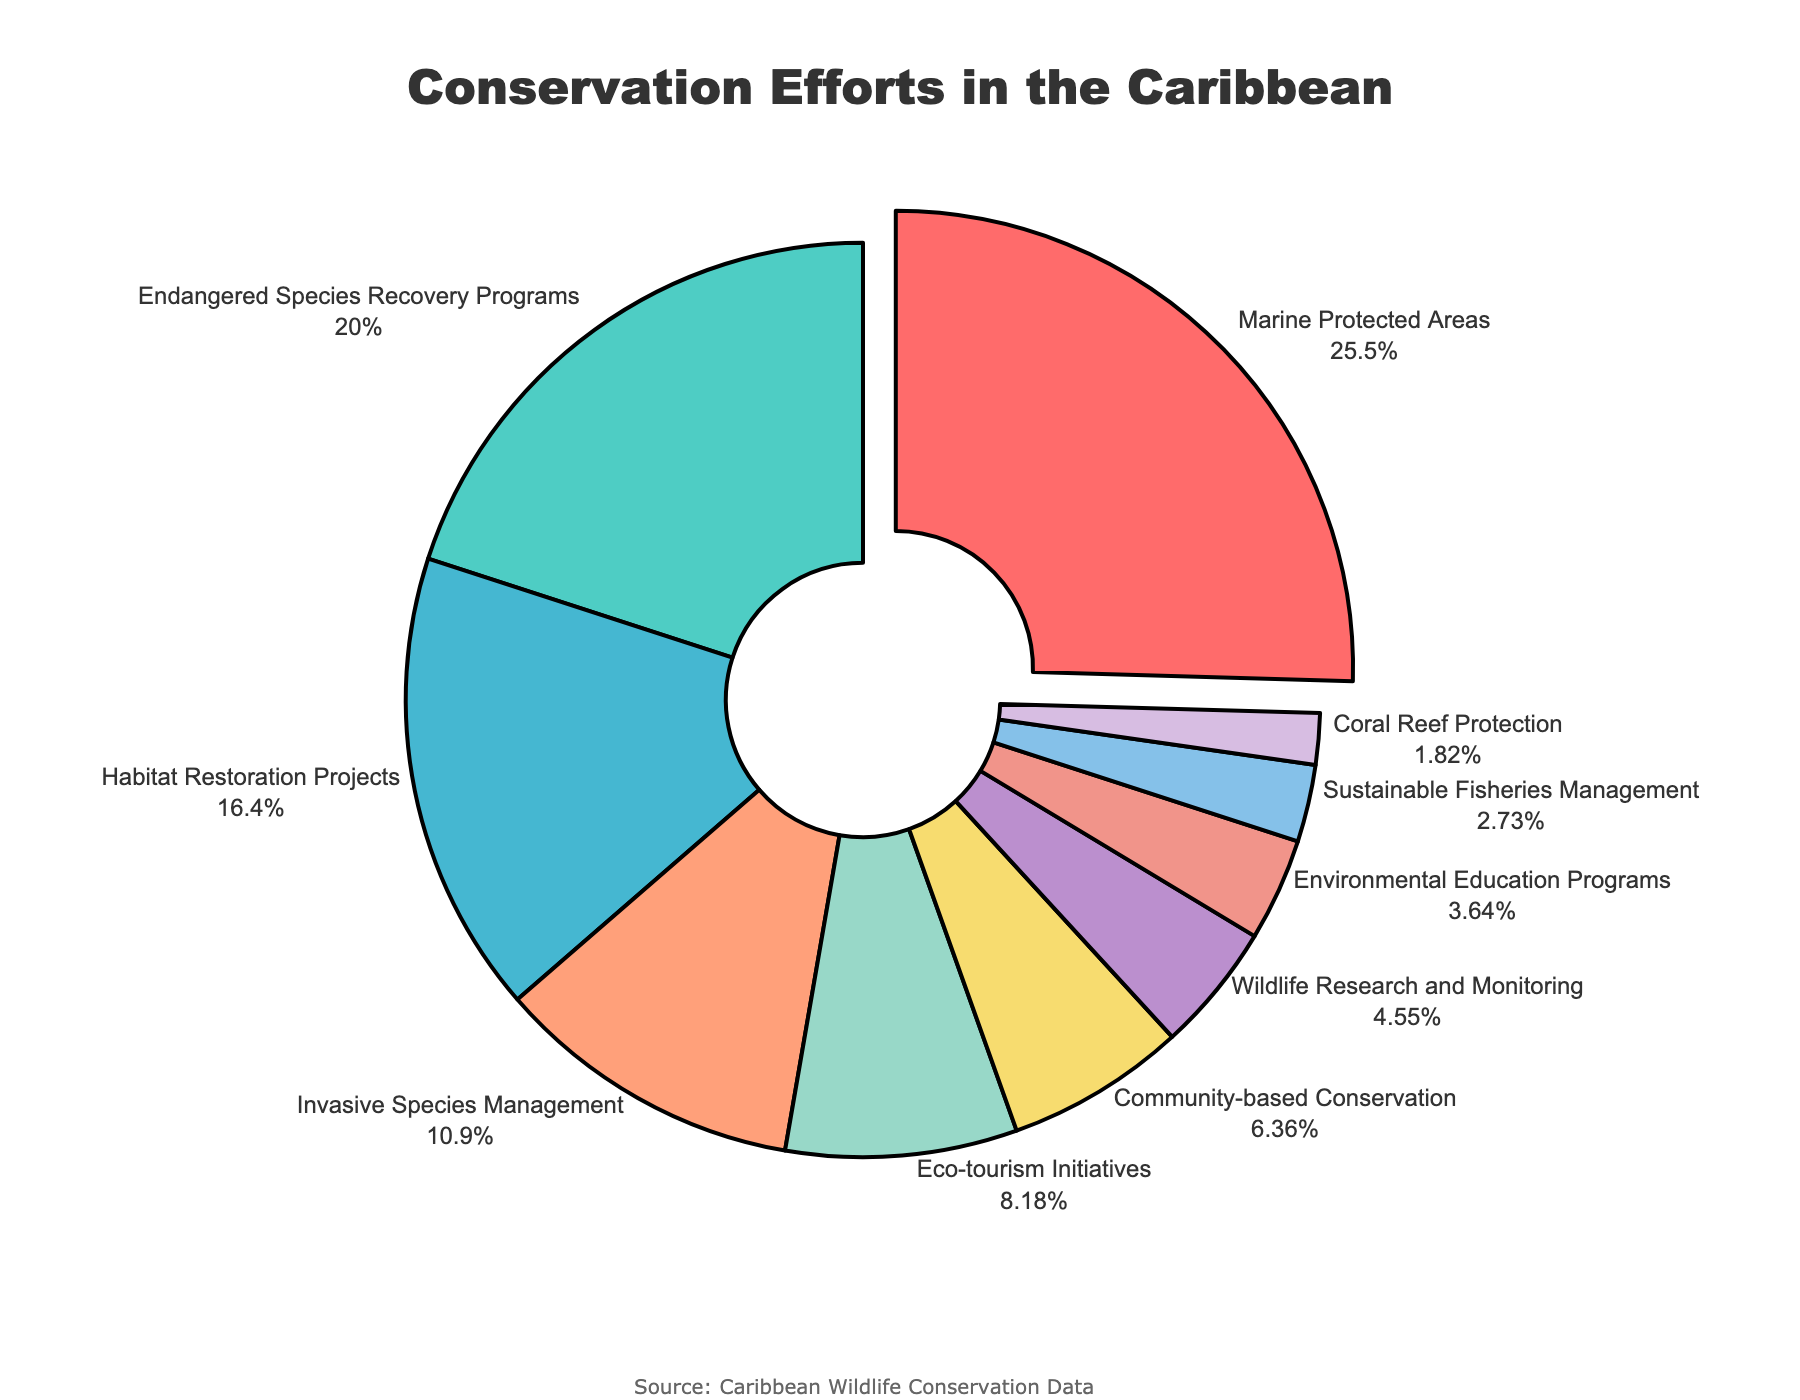What's the largest conservation effort by percentage? The figure shows various types of conservation efforts along with their percentage shares. By looking at the percentages, the largest conservation effort is the one with the highest percentage.
Answer: Marine Protected Areas Which two efforts occupy the smallest percentage combined? To find the smallest combined percentage, identify the two conservation efforts with the smallest individual percentages and add them together. The smallest percentages are Coral Reef Protection (2%) and Sustainable Fisheries Management (3%). Adding these values gives 2% + 3% = 5%.
Answer: Coral Reef Protection and Sustainable Fisheries Management How much larger is the percentage for Marine Protected Areas compared to Wildlife Research and Monitoring? First, find the percentage for both categories: Marine Protected Areas (28%) and Wildlife Research and Monitoring (5%). Then calculate the difference: 28% - 5% = 23%.
Answer: 23% What's the combined percentage of Eco-tourism Initiatives and Community-based Conservation? Look for the percentages of these two efforts: Eco-tourism Initiatives (9%) and Community-based Conservation (7%). Adding these values gives 9% + 7% = 16%.
Answer: 16% Which category is represented by the green section in the pie chart? The green section corresponds to the color code used in the chart. Identify which segment uses green and match it to the category label.
Answer: Endangered Species Recovery Programs Are there more efforts devoted to Habitat Restoration Projects or Endangered Species Recovery Programs? Compare the percentages: Habitat Restoration Projects (18%) vs. Endangered Species Recovery Programs (22%). Since 22% is greater than 18%, more efforts are devoted to Endangered Species Recovery Programs.
Answer: Endangered Species Recovery Programs What is the total percentage of efforts that are below 10%? Identify the categories with percentages below 10%: Eco-tourism Initiatives (9%), Community-based Conservation (7%), Wildlife Research and Monitoring (5%), Environmental Education Programs (4%), Sustainable Fisheries Management (3%), and Coral Reef Protection (2%). Then add these percentages: 9% + 7% + 5% + 4% + 3% + 2% = 30%.
Answer: 30% Which group falls under the category represented by a blue segment with the thickest border? The blue segment with the thickest border is usually highlighted or pulled out. Look for the category where the pie slice is slightly separated and colored blue.
Answer: Marine Protected Areas 